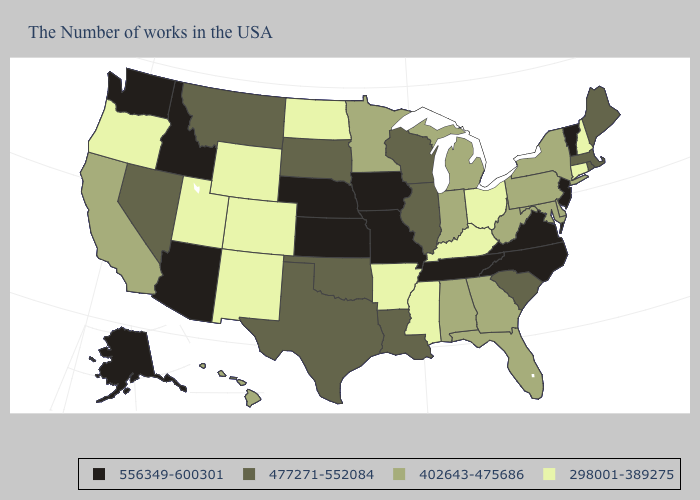What is the lowest value in states that border Indiana?
Quick response, please. 298001-389275. Name the states that have a value in the range 477271-552084?
Short answer required. Maine, Massachusetts, Rhode Island, South Carolina, Wisconsin, Illinois, Louisiana, Oklahoma, Texas, South Dakota, Montana, Nevada. Which states hav the highest value in the West?
Quick response, please. Arizona, Idaho, Washington, Alaska. Among the states that border Wisconsin , which have the lowest value?
Write a very short answer. Michigan, Minnesota. Does Georgia have the highest value in the USA?
Keep it brief. No. What is the lowest value in the South?
Give a very brief answer. 298001-389275. Does Idaho have a lower value than Vermont?
Concise answer only. No. Name the states that have a value in the range 556349-600301?
Write a very short answer. Vermont, New Jersey, Virginia, North Carolina, Tennessee, Missouri, Iowa, Kansas, Nebraska, Arizona, Idaho, Washington, Alaska. Which states have the highest value in the USA?
Write a very short answer. Vermont, New Jersey, Virginia, North Carolina, Tennessee, Missouri, Iowa, Kansas, Nebraska, Arizona, Idaho, Washington, Alaska. What is the value of Maryland?
Answer briefly. 402643-475686. Name the states that have a value in the range 477271-552084?
Answer briefly. Maine, Massachusetts, Rhode Island, South Carolina, Wisconsin, Illinois, Louisiana, Oklahoma, Texas, South Dakota, Montana, Nevada. Does the map have missing data?
Short answer required. No. Does the first symbol in the legend represent the smallest category?
Short answer required. No. Among the states that border Missouri , does Arkansas have the lowest value?
Give a very brief answer. Yes. Which states have the highest value in the USA?
Short answer required. Vermont, New Jersey, Virginia, North Carolina, Tennessee, Missouri, Iowa, Kansas, Nebraska, Arizona, Idaho, Washington, Alaska. 